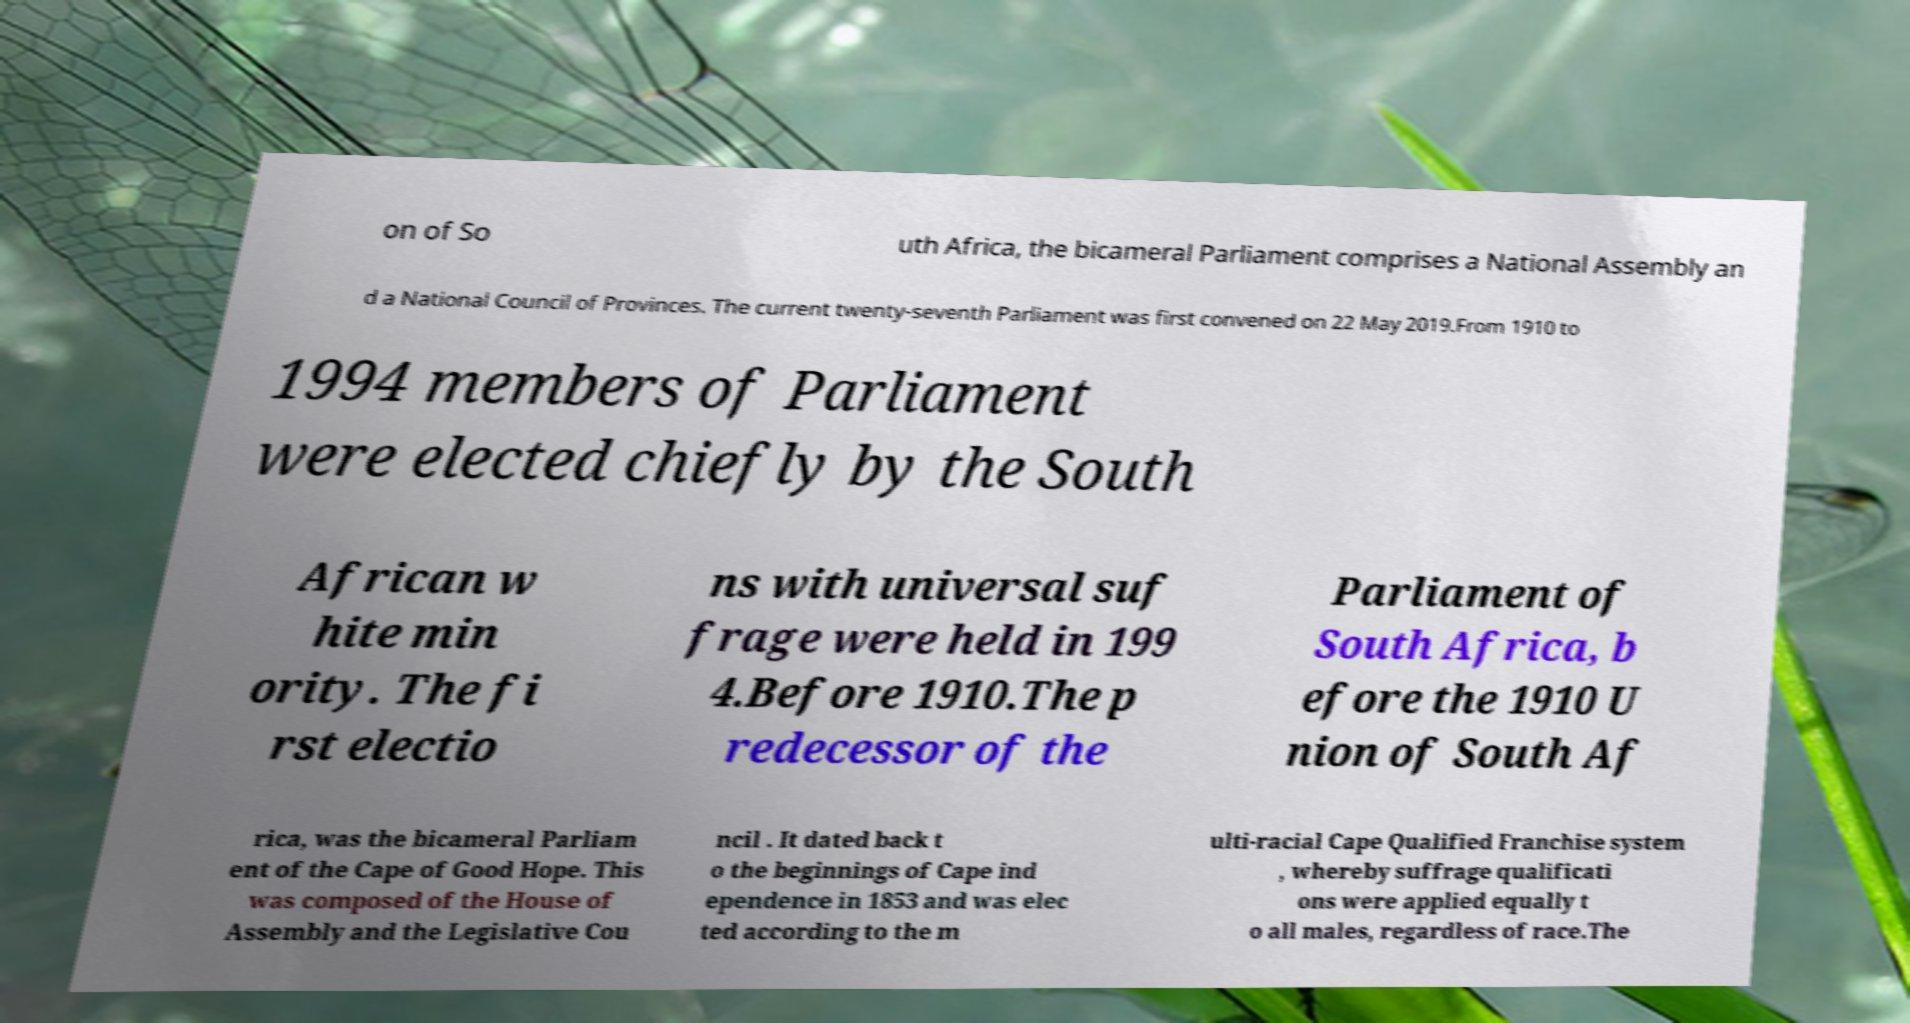Can you read and provide the text displayed in the image?This photo seems to have some interesting text. Can you extract and type it out for me? on of So uth Africa, the bicameral Parliament comprises a National Assembly an d a National Council of Provinces. The current twenty-seventh Parliament was first convened on 22 May 2019.From 1910 to 1994 members of Parliament were elected chiefly by the South African w hite min ority. The fi rst electio ns with universal suf frage were held in 199 4.Before 1910.The p redecessor of the Parliament of South Africa, b efore the 1910 U nion of South Af rica, was the bicameral Parliam ent of the Cape of Good Hope. This was composed of the House of Assembly and the Legislative Cou ncil . It dated back t o the beginnings of Cape ind ependence in 1853 and was elec ted according to the m ulti-racial Cape Qualified Franchise system , whereby suffrage qualificati ons were applied equally t o all males, regardless of race.The 